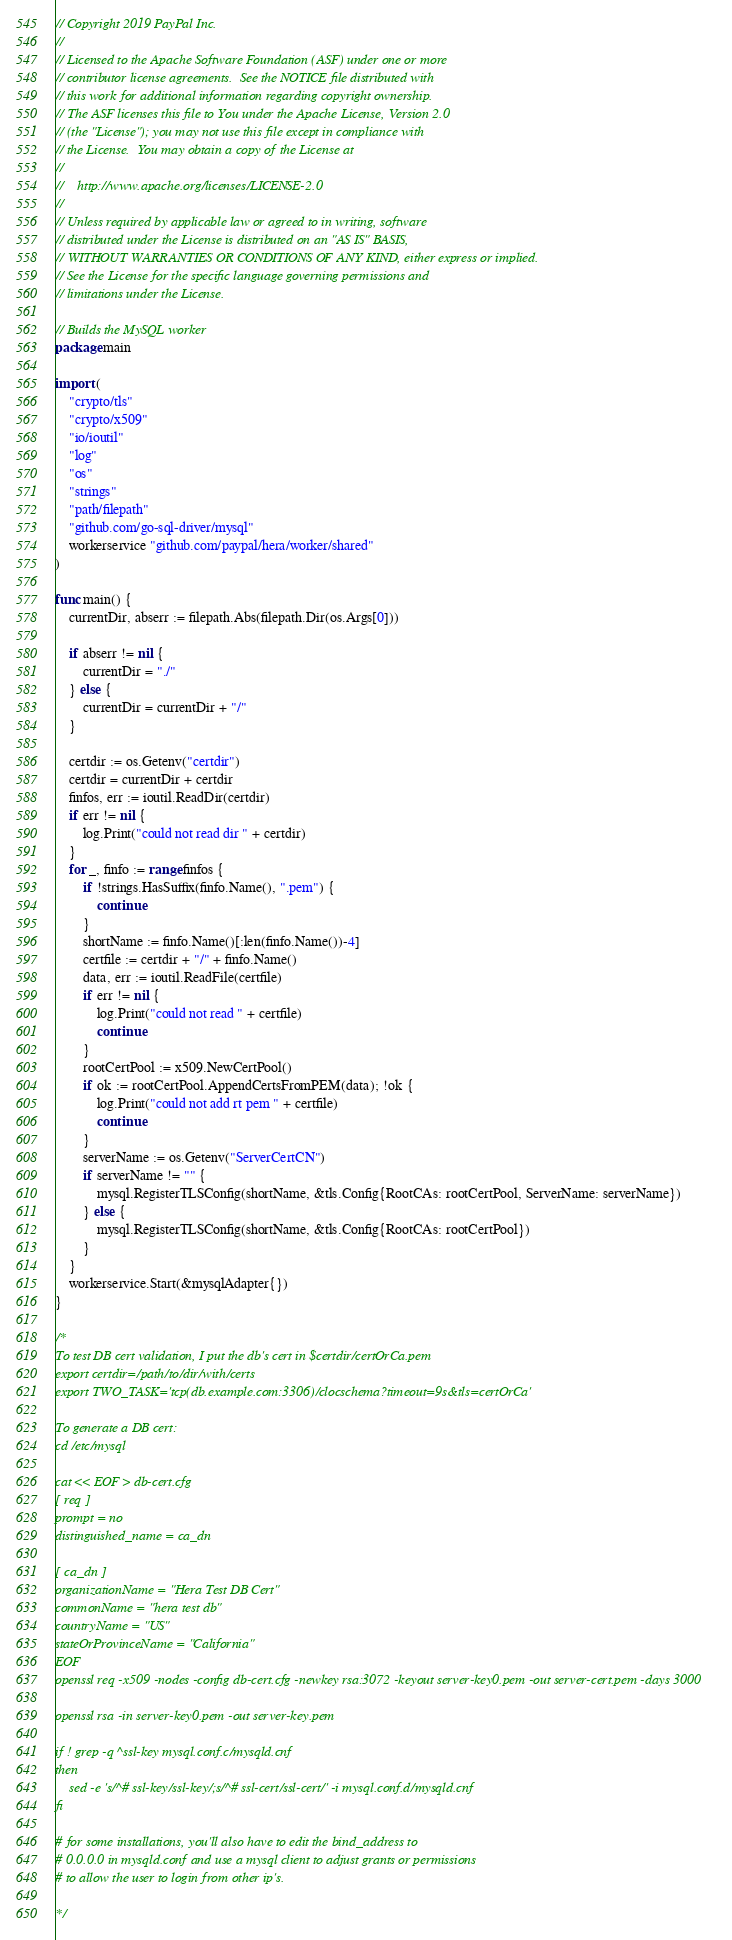<code> <loc_0><loc_0><loc_500><loc_500><_Go_>// Copyright 2019 PayPal Inc.
//
// Licensed to the Apache Software Foundation (ASF) under one or more
// contributor license agreements.  See the NOTICE file distributed with
// this work for additional information regarding copyright ownership.
// The ASF licenses this file to You under the Apache License, Version 2.0
// (the "License"); you may not use this file except in compliance with
// the License.  You may obtain a copy of the License at
//
//    http://www.apache.org/licenses/LICENSE-2.0
//
// Unless required by applicable law or agreed to in writing, software
// distributed under the License is distributed on an "AS IS" BASIS,
// WITHOUT WARRANTIES OR CONDITIONS OF ANY KIND, either express or implied.
// See the License for the specific language governing permissions and
// limitations under the License.

// Builds the MySQL worker
package main

import (
	"crypto/tls"
	"crypto/x509"
	"io/ioutil"
	"log"
	"os"
	"strings"
	"path/filepath"
	"github.com/go-sql-driver/mysql"
	workerservice "github.com/paypal/hera/worker/shared"
)

func main() {
	currentDir, abserr := filepath.Abs(filepath.Dir(os.Args[0]))
	
	if abserr != nil {
		currentDir = "./"
	} else {
		currentDir = currentDir + "/"
	}

	certdir := os.Getenv("certdir")
	certdir = currentDir + certdir
	finfos, err := ioutil.ReadDir(certdir)
	if err != nil {
		log.Print("could not read dir " + certdir)
	}
	for _, finfo := range finfos {
		if !strings.HasSuffix(finfo.Name(), ".pem") {
			continue
		}
		shortName := finfo.Name()[:len(finfo.Name())-4]
		certfile := certdir + "/" + finfo.Name()
		data, err := ioutil.ReadFile(certfile)
		if err != nil {
			log.Print("could not read " + certfile)
			continue
		}
		rootCertPool := x509.NewCertPool()
		if ok := rootCertPool.AppendCertsFromPEM(data); !ok {
			log.Print("could not add rt pem " + certfile)
			continue
		}
		serverName := os.Getenv("ServerCertCN")
		if serverName != "" {
			mysql.RegisterTLSConfig(shortName, &tls.Config{RootCAs: rootCertPool, ServerName: serverName})
		} else {
			mysql.RegisterTLSConfig(shortName, &tls.Config{RootCAs: rootCertPool})
		}
	}
	workerservice.Start(&mysqlAdapter{})
}

/*
To test DB cert validation, I put the db's cert in $certdir/certOrCa.pem
export certdir=/path/to/dir/with/certs
export TWO_TASK='tcp(db.example.com:3306)/clocschema?timeout=9s&tls=certOrCa'

To generate a DB cert:
cd /etc/mysql

cat << EOF > db-cert.cfg
[ req ]
prompt = no
distinguished_name = ca_dn

[ ca_dn ]
organizationName = "Hera Test DB Cert"
commonName = "hera test db"
countryName = "US"
stateOrProvinceName = "California"
EOF
openssl req -x509 -nodes -config db-cert.cfg -newkey rsa:3072 -keyout server-key0.pem -out server-cert.pem -days 3000

openssl rsa -in server-key0.pem -out server-key.pem

if ! grep -q ^ssl-key mysql.conf.c/mysqld.cnf
then
    sed -e 's/^# ssl-key/ssl-key/;s/^# ssl-cert/ssl-cert/' -i mysql.conf.d/mysqld.cnf
fi

# for some installations, you'll also have to edit the bind_address to
# 0.0.0.0 in mysqld.conf and use a mysql client to adjust grants or permissions
# to allow the user to login from other ip's.

*/
</code> 